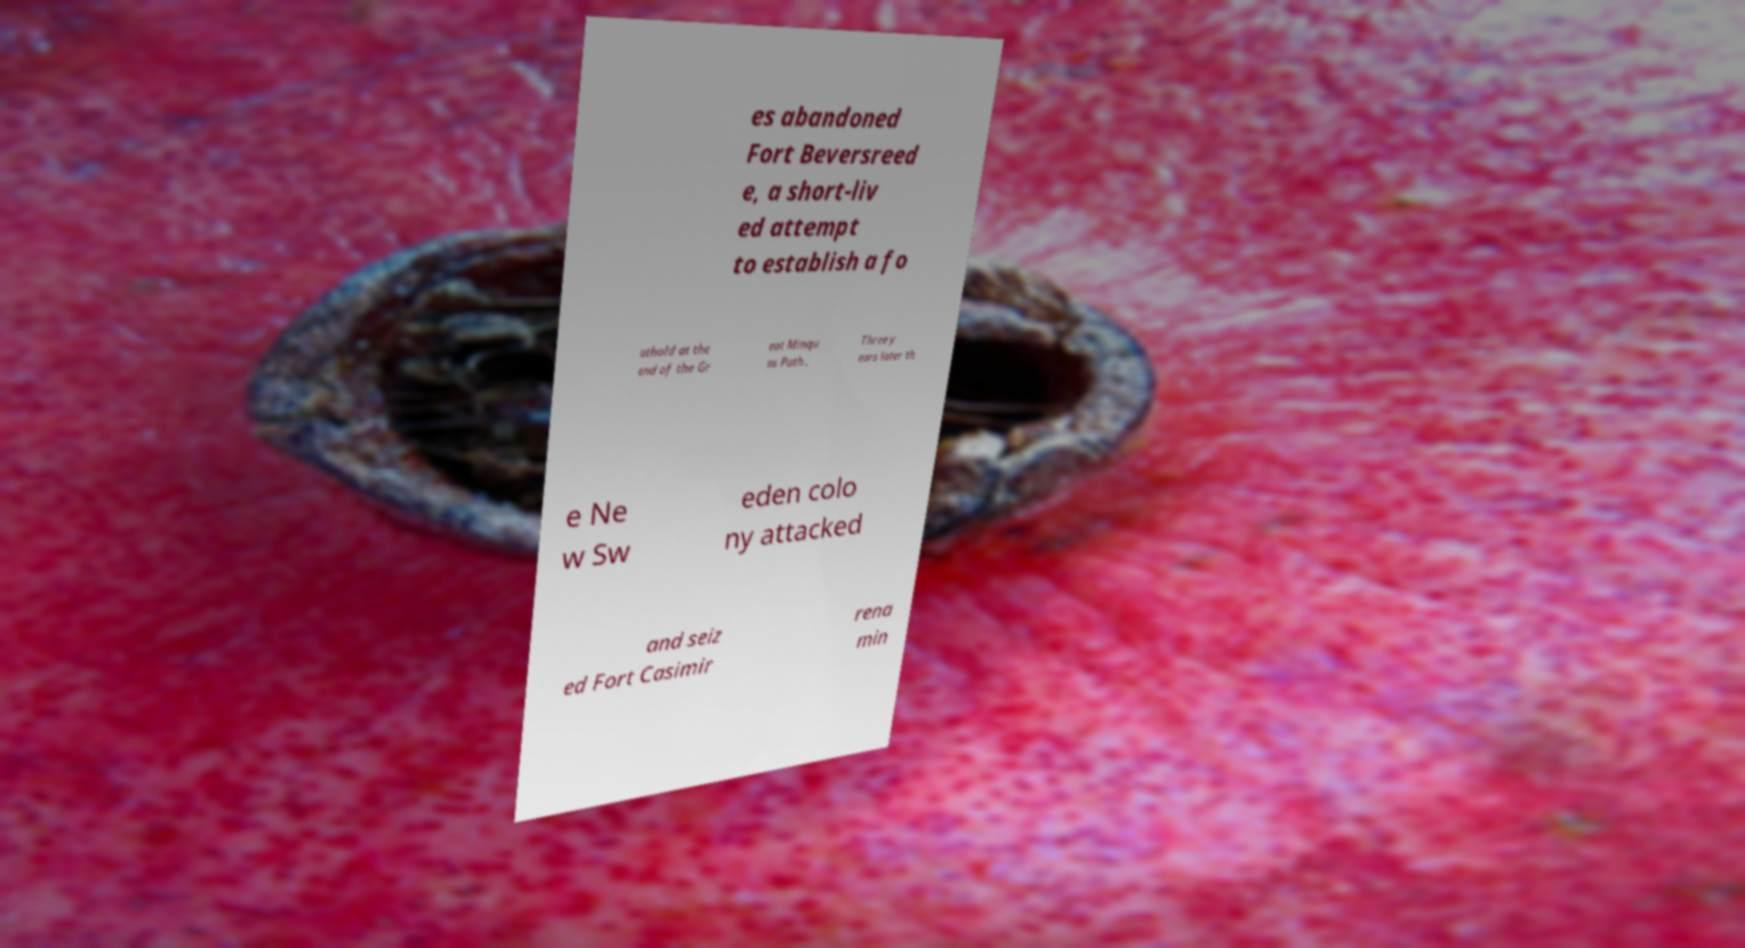There's text embedded in this image that I need extracted. Can you transcribe it verbatim? es abandoned Fort Beversreed e, a short-liv ed attempt to establish a fo othold at the end of the Gr eat Minqu as Path . Three y ears later th e Ne w Sw eden colo ny attacked and seiz ed Fort Casimir rena min 